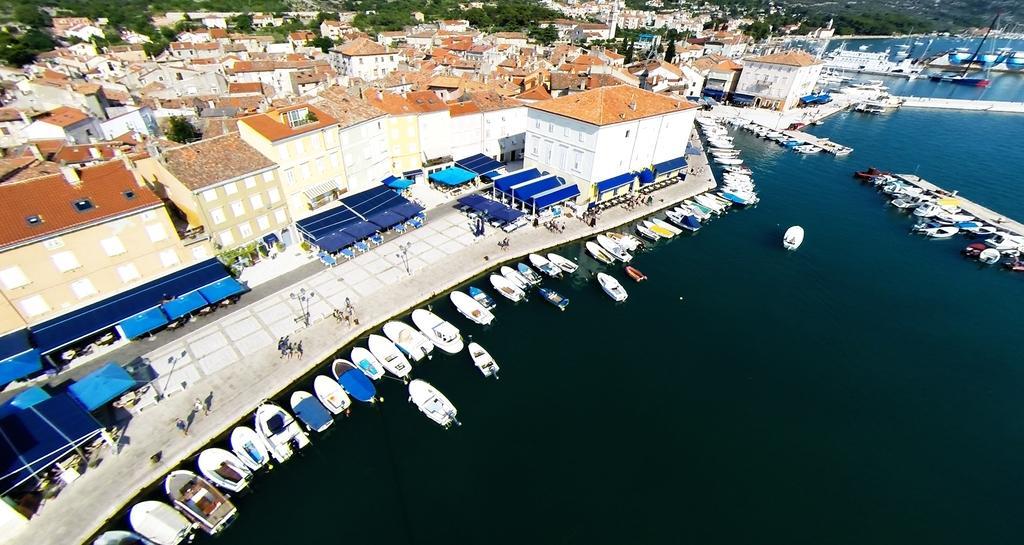Describe this image in one or two sentences. This is the picture of a city. In the foreground there are boats on the water. At the back there are buildings, trees and there are group of people walking on the road and there are poles on the footpath. 